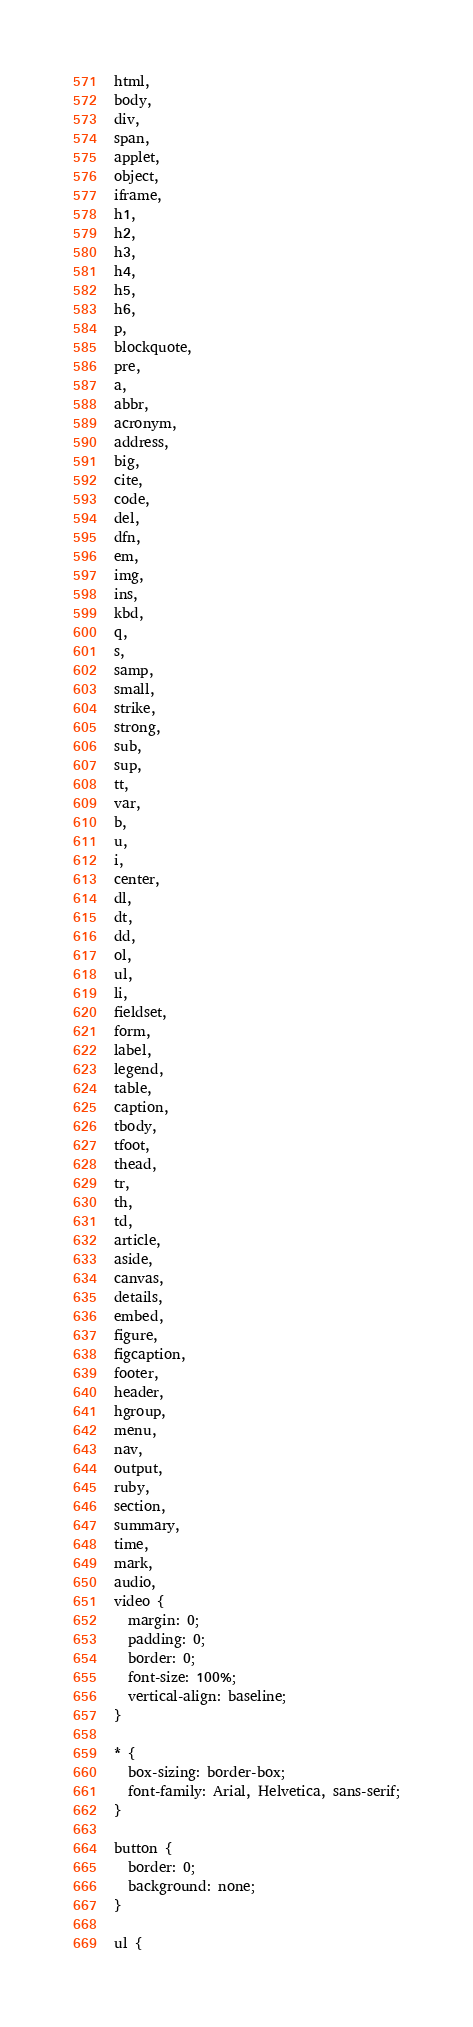<code> <loc_0><loc_0><loc_500><loc_500><_CSS_>html,
body,
div,
span,
applet,
object,
iframe,
h1,
h2,
h3,
h4,
h5,
h6,
p,
blockquote,
pre,
a,
abbr,
acronym,
address,
big,
cite,
code,
del,
dfn,
em,
img,
ins,
kbd,
q,
s,
samp,
small,
strike,
strong,
sub,
sup,
tt,
var,
b,
u,
i,
center,
dl,
dt,
dd,
ol,
ul,
li,
fieldset,
form,
label,
legend,
table,
caption,
tbody,
tfoot,
thead,
tr,
th,
td,
article,
aside,
canvas,
details,
embed,
figure,
figcaption,
footer,
header,
hgroup,
menu,
nav,
output,
ruby,
section,
summary,
time,
mark,
audio,
video {
  margin: 0;
  padding: 0;
  border: 0;
  font-size: 100%;
  vertical-align: baseline;
}

* {
  box-sizing: border-box;
  font-family: Arial, Helvetica, sans-serif;
}

button {
  border: 0;
  background: none;
}

ul {</code> 